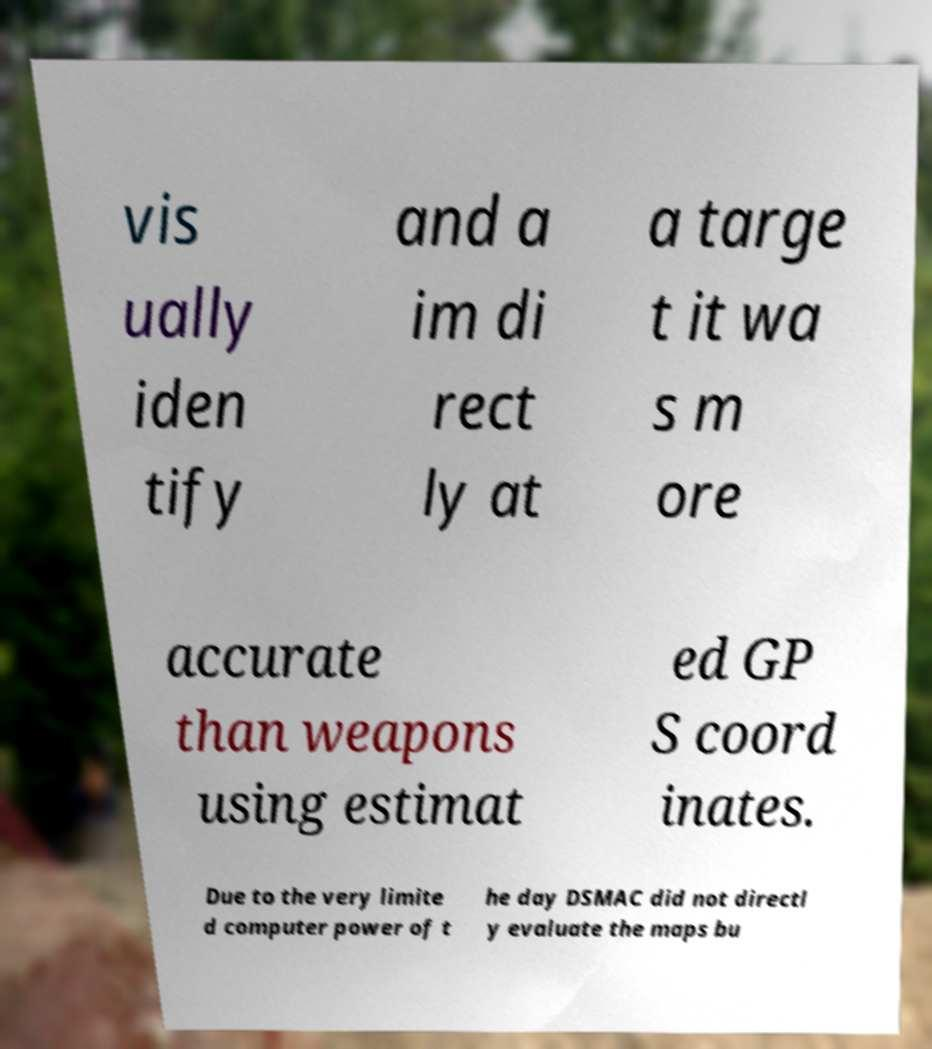Can you accurately transcribe the text from the provided image for me? vis ually iden tify and a im di rect ly at a targe t it wa s m ore accurate than weapons using estimat ed GP S coord inates. Due to the very limite d computer power of t he day DSMAC did not directl y evaluate the maps bu 